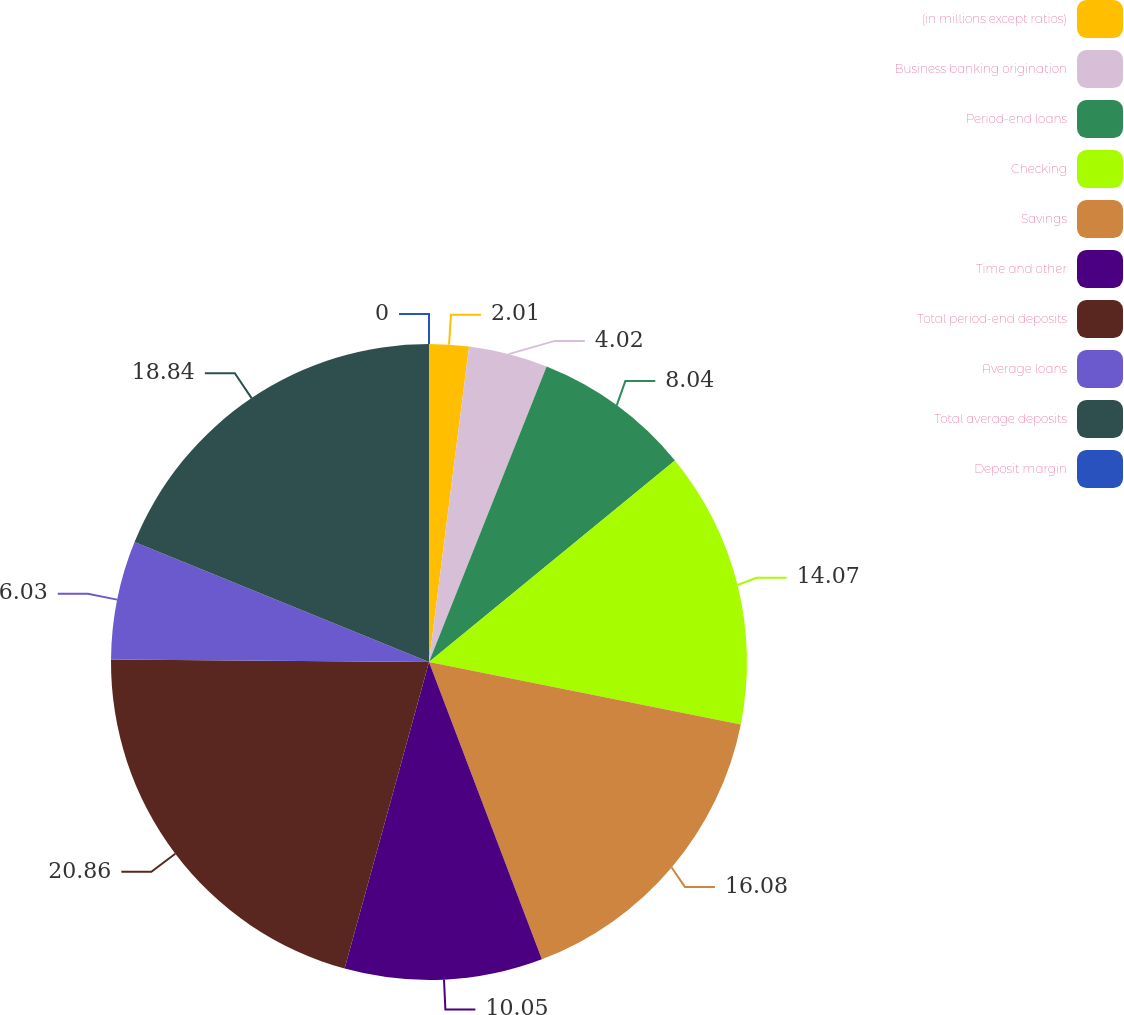Convert chart. <chart><loc_0><loc_0><loc_500><loc_500><pie_chart><fcel>(in millions except ratios)<fcel>Business banking origination<fcel>Period-end loans<fcel>Checking<fcel>Savings<fcel>Time and other<fcel>Total period-end deposits<fcel>Average loans<fcel>Total average deposits<fcel>Deposit margin<nl><fcel>2.01%<fcel>4.02%<fcel>8.04%<fcel>14.07%<fcel>16.08%<fcel>10.05%<fcel>20.85%<fcel>6.03%<fcel>18.84%<fcel>0.0%<nl></chart> 